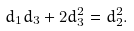<formula> <loc_0><loc_0><loc_500><loc_500>d _ { 1 } d _ { 3 } + 2 d _ { 3 } ^ { 2 } = d _ { 2 } ^ { 2 } .</formula> 